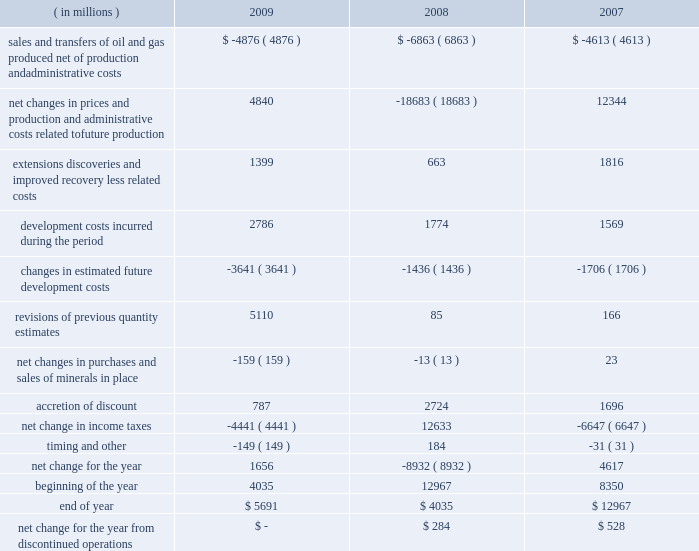Supplementary information on oil and gas producing activities ( unaudited ) changes in the standardized measure of discounted future net cash flows .

In millions , what was the average net change in discounted future cash flows for the three year period? 
Computations: table_average(net change for the year, none)
Answer: -886.33333. 